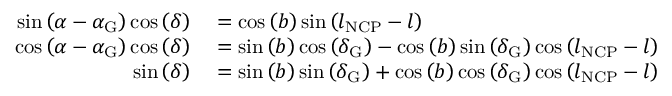Convert formula to latex. <formula><loc_0><loc_0><loc_500><loc_500>\begin{array} { r l } { \sin \left ( \alpha - \alpha _ { G } \right ) \cos \left ( \delta \right ) } & = \cos \left ( b \right ) \sin \left ( l _ { N C P } - l \right ) } \\ { \cos \left ( \alpha - \alpha _ { G } \right ) \cos \left ( \delta \right ) } & = \sin \left ( b \right ) \cos \left ( \delta _ { G } \right ) - \cos \left ( b \right ) \sin \left ( \delta _ { G } \right ) \cos \left ( l _ { N C P } - l \right ) } \\ { \sin \left ( \delta \right ) } & = \sin \left ( b \right ) \sin \left ( \delta _ { G } \right ) + \cos \left ( b \right ) \cos \left ( \delta _ { G } \right ) \cos \left ( l _ { N C P } - l \right ) } \end{array}</formula> 